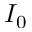Convert formula to latex. <formula><loc_0><loc_0><loc_500><loc_500>I _ { 0 }</formula> 